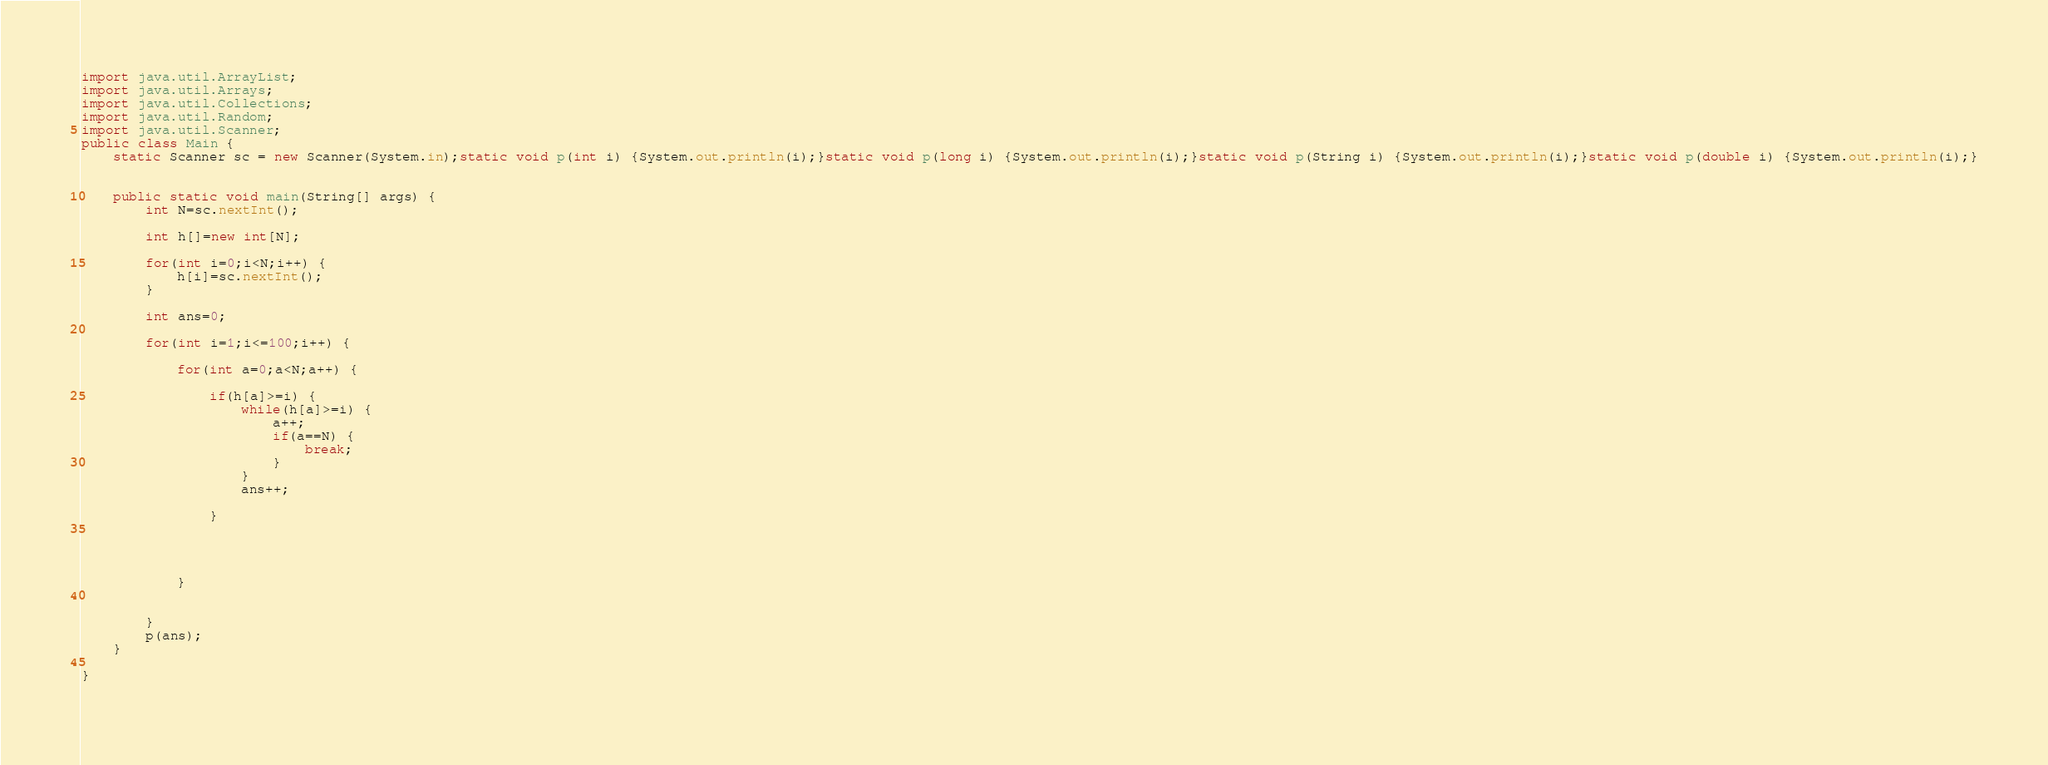Convert code to text. <code><loc_0><loc_0><loc_500><loc_500><_Java_>import java.util.ArrayList;
import java.util.Arrays;
import java.util.Collections;
import java.util.Random;
import java.util.Scanner;
public class Main {
	static Scanner sc = new Scanner(System.in);static void p(int i) {System.out.println(i);}static void p(long i) {System.out.println(i);}static void p(String i) {System.out.println(i);}static void p(double i) {System.out.println(i);}
	
	
	public static void main(String[] args) {
		int N=sc.nextInt();
		
		int h[]=new int[N];
		
		for(int i=0;i<N;i++) {
			h[i]=sc.nextInt();
		}
		
		int ans=0;
		
		for(int i=1;i<=100;i++) {
			
			for(int a=0;a<N;a++) {
				
				if(h[a]>=i) {
					while(h[a]>=i) {
						a++;
						if(a==N) {
							break;
						}
					}
					ans++;
					
				}
				
				
				
				
			}
			
			
		}
		p(ans);
	}
	
}
	
</code> 